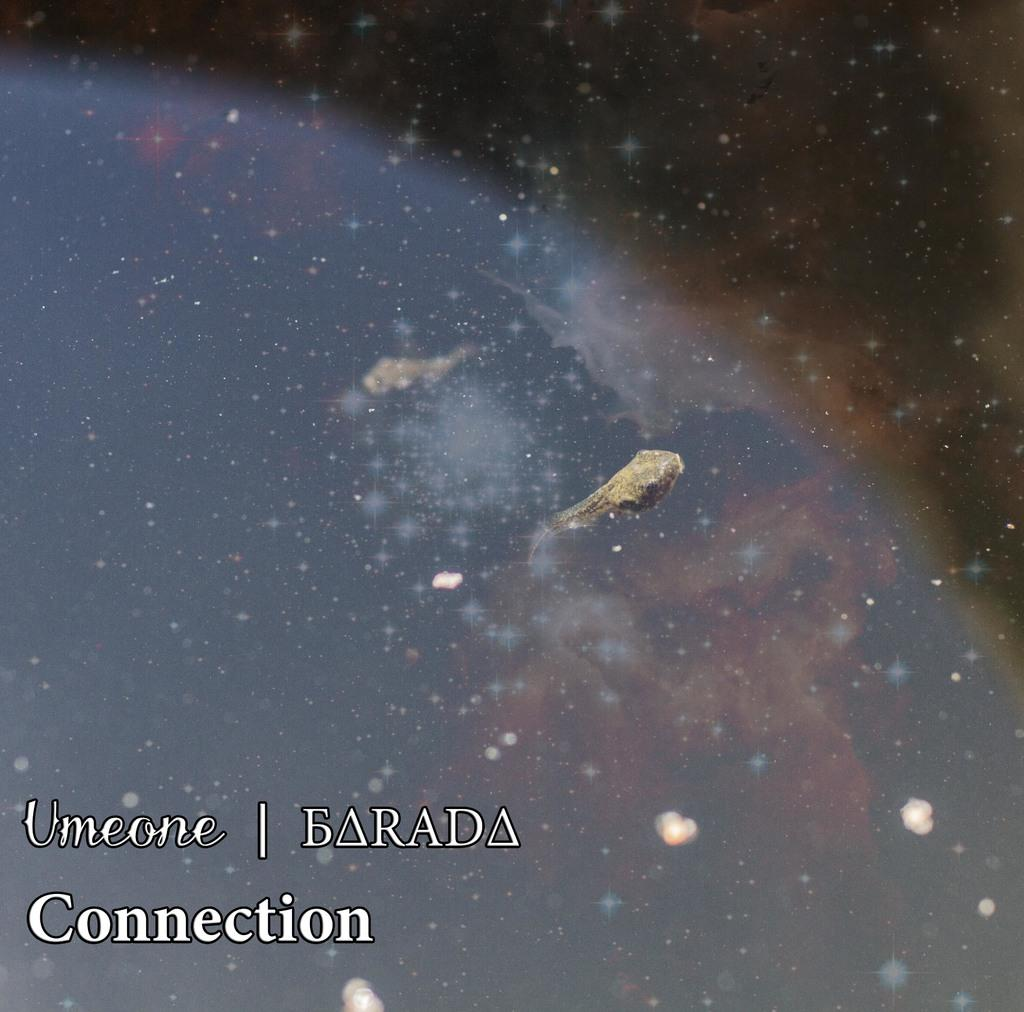What is the main subject of the image? The main subject of the image is a space. Can you describe any text that is present in the image? Yes, there is text at the bottom of the image. What type of zephyr can be seen blowing through the drain in the image? There is no zephyr or drain present in the image; it features a space and text at the bottom. 